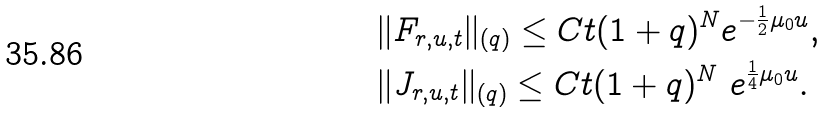<formula> <loc_0><loc_0><loc_500><loc_500>& \| F _ { r , u , t } \| _ { ( q ) } \leq C t ( 1 + q ) ^ { N } e ^ { - \frac { 1 } { 2 } \mu _ { 0 } u } , \\ & \| J _ { r , u , t } \| _ { ( q ) } \leq C t ( 1 + q ) ^ { N } \ e ^ { \frac { 1 } { 4 } \mu _ { 0 } u } .</formula> 